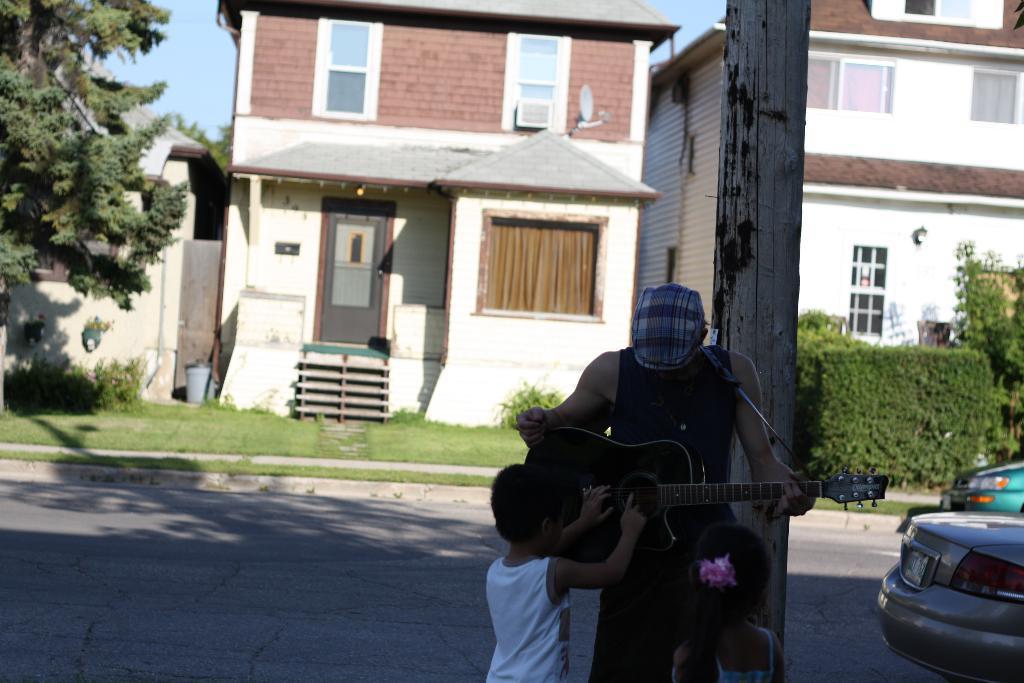Describe this image in one or two sentences. In this picture we can see three persons are standing on the road. He is holding a guitar with his hands. These are the vehicles. Here we can see some plants. And this is a house and there is a tree. Here we can see grass and this is sky. 